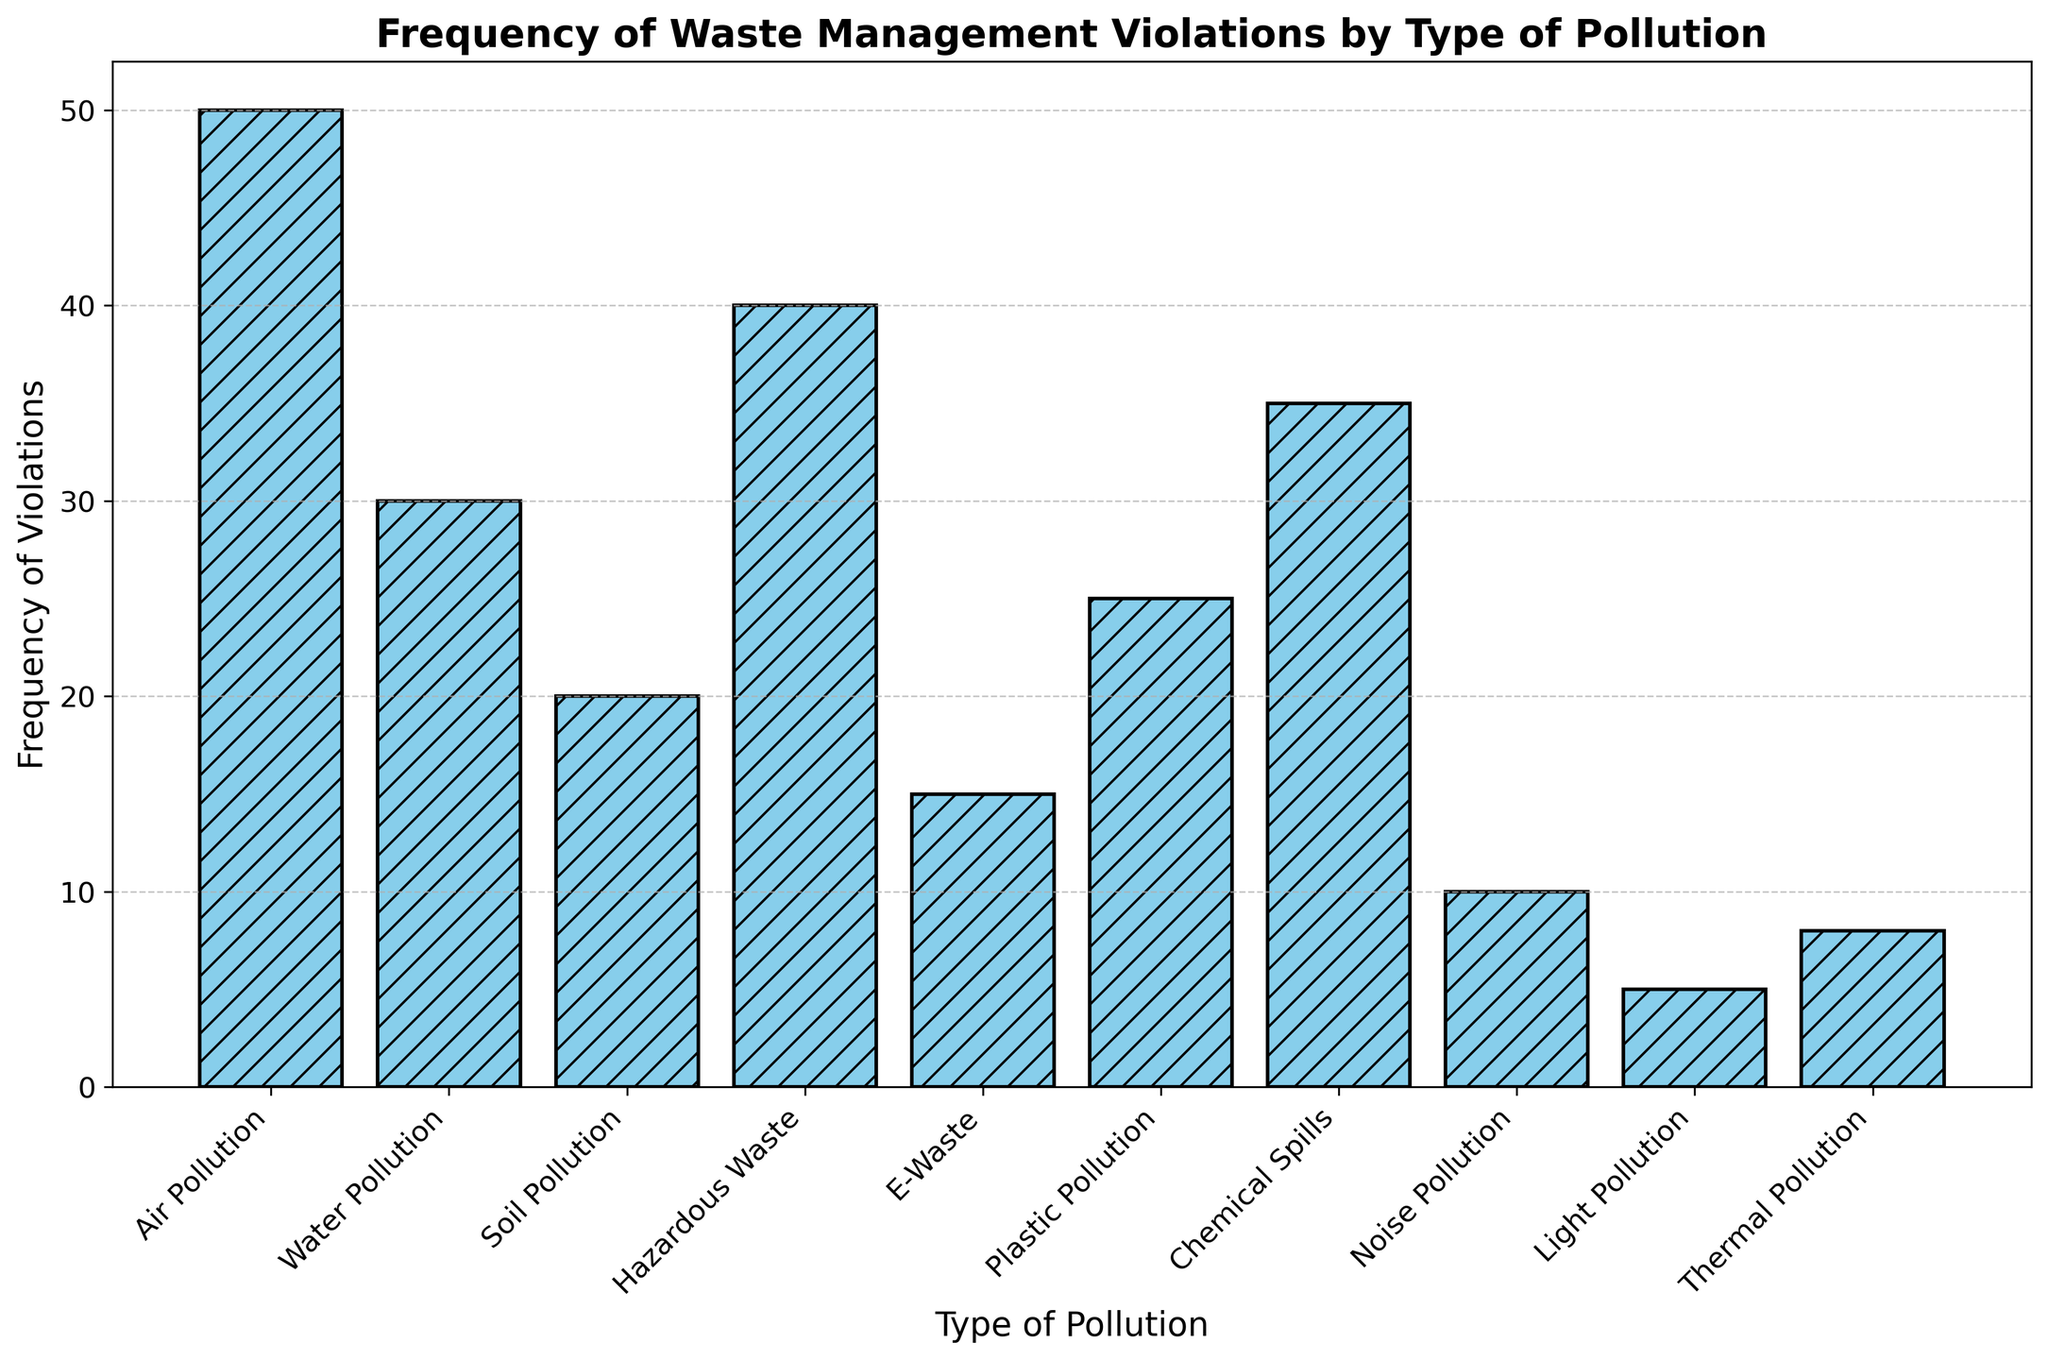What's the most frequently violated type of pollution? Looking at the histogram, the tallest bar represents the type of pollution with the most frequent violations.
Answer: Air Pollution Which type of pollution has the least number of violations? The shortest bar on the histogram indicates the type of pollution with the fewest violations.
Answer: Light Pollution How many more violations does Air Pollution have compared to E-Waste? Count the height differences of the bars for Air Pollution and E-Waste. Air Pollution has 50 violations, and E-Waste has 15. Subtract these values to find the difference. 50 - 15 = 35
Answer: 35 What is the average frequency of violations for Water Pollution, Soil Pollution, and Plastic Pollution? Add the frequency of violations for Water Pollution (30), Soil Pollution (20), and Plastic Pollution (25), and then divide by the number of types (3). (30 + 20 + 25) / 3 = 75 / 3 = 25
Answer: 25 What percentage of the total violations does Hazardous Waste account for? Sum the frequencies of all types of pollution to get the total number of violations. Then, divide the frequency of Hazardous Waste by the total and multiply by 100. The total is 238. (100 * 40) / 238 = 16.81%
Answer: 16.81% Are violations for Noise Pollution more or less frequent than for Thermal Pollution? Compare the heights of the bars for Noise Pollution and Thermal Pollution. Noise Pollution has 10 violations, and Thermal Pollution has 8.
Answer: More What is the sum of frequencies for Chemical Spills and Plastic Pollution? Add the frequency of violations for Chemical Spills (35) and Plastic Pollution (25). 35 + 25 = 60
Answer: 60 Which type of pollution is the third most frequently violated? Identify the types of pollution by the height of their bars. Air Pollution (50) ranks first, Hazardous Waste (40) second, and Chemical Spills (35) third.
Answer: Chemical Spills How many types of pollution have more than 30 violations? Count the number of bars that exceed the 30 mark on the y-axis. Air Pollution (50), Hazardous Waste (40), and Chemical Spills (35) meet this criterion.
Answer: 3 What is the median frequency of violations across all types of pollution? Arrange the frequencies in ascending order: 5, 8, 10, 15, 20, 25, 30, 35, 40, 50. The median is the middle value of this ordered list. When there are ten values, the median is the average of the 5th and 6th values: (20 + 25) / 2 = 22.5
Answer: 22.5 